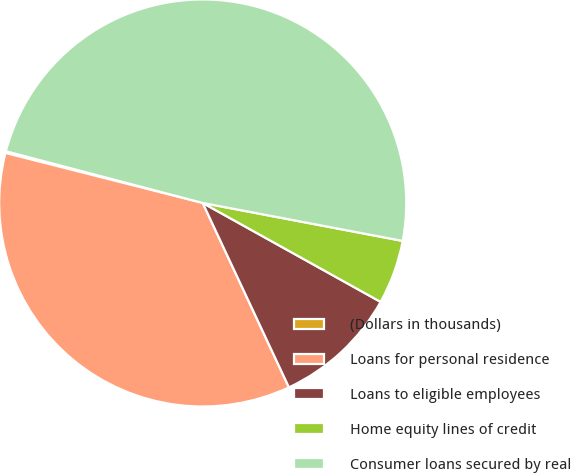Convert chart. <chart><loc_0><loc_0><loc_500><loc_500><pie_chart><fcel>(Dollars in thousands)<fcel>Loans for personal residence<fcel>Loans to eligible employees<fcel>Home equity lines of credit<fcel>Consumer loans secured by real<nl><fcel>0.14%<fcel>35.91%<fcel>9.96%<fcel>5.09%<fcel>48.89%<nl></chart> 